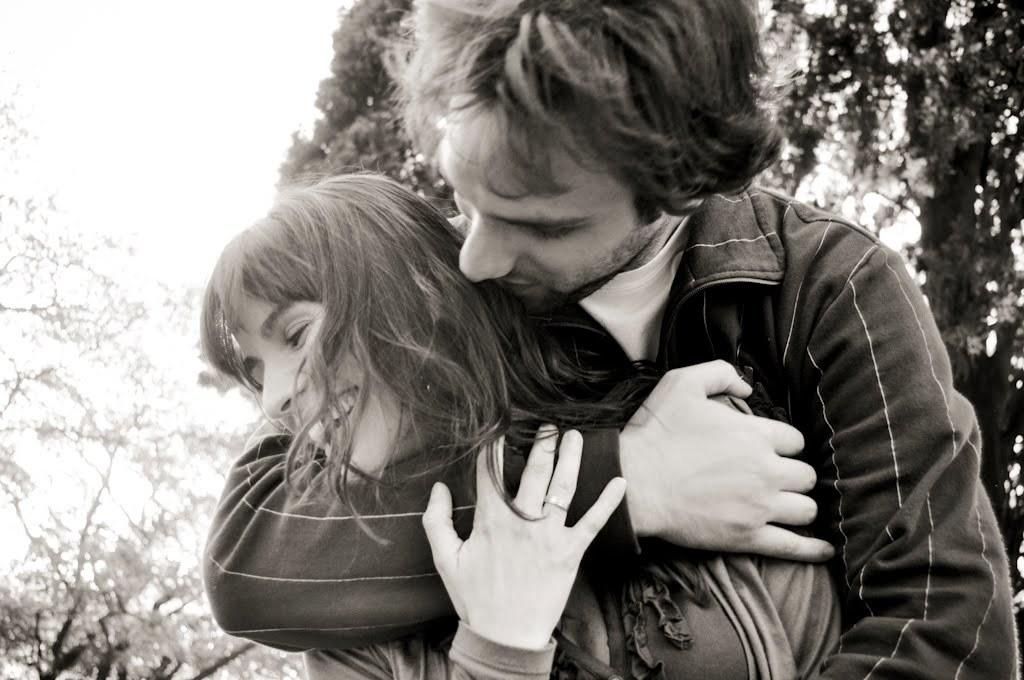Who is present in the image? There is a couple in the image. What are the couple doing in the image? The couple is holding each other. What can be seen in the background of the image? There are trees in the background of the image. How many boxes can be seen in the image? There are no boxes present in the image. What type of bikes are visible in the image? There are no bikes present in the image. 